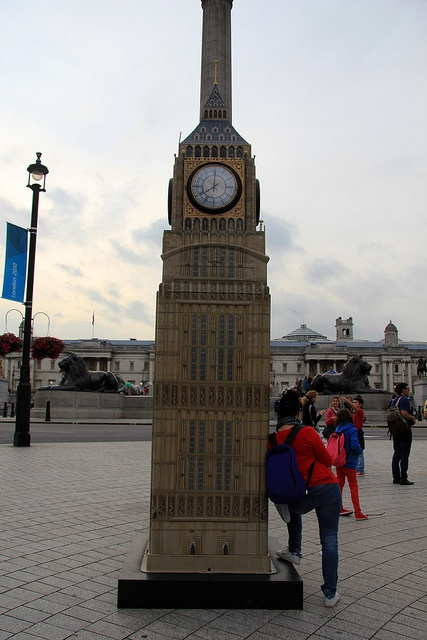Describe the objects in this image and their specific colors. I can see people in lavender, black, maroon, and gray tones, backpack in lavender, black, maroon, navy, and gray tones, people in lavender, black, maroon, navy, and brown tones, people in lavender, black, gray, and maroon tones, and clock in lavender and gray tones in this image. 